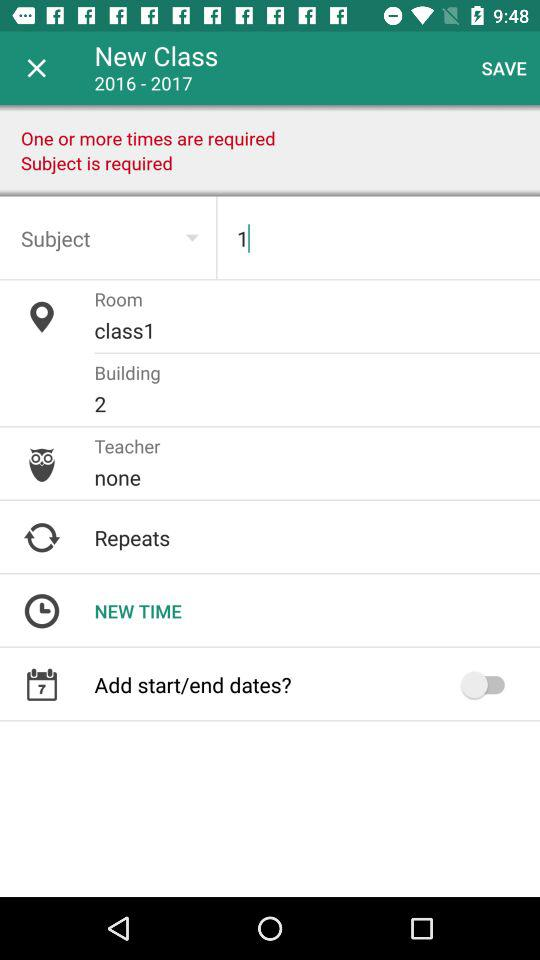How many times must the class meet?
Answer the question using a single word or phrase. One or more 